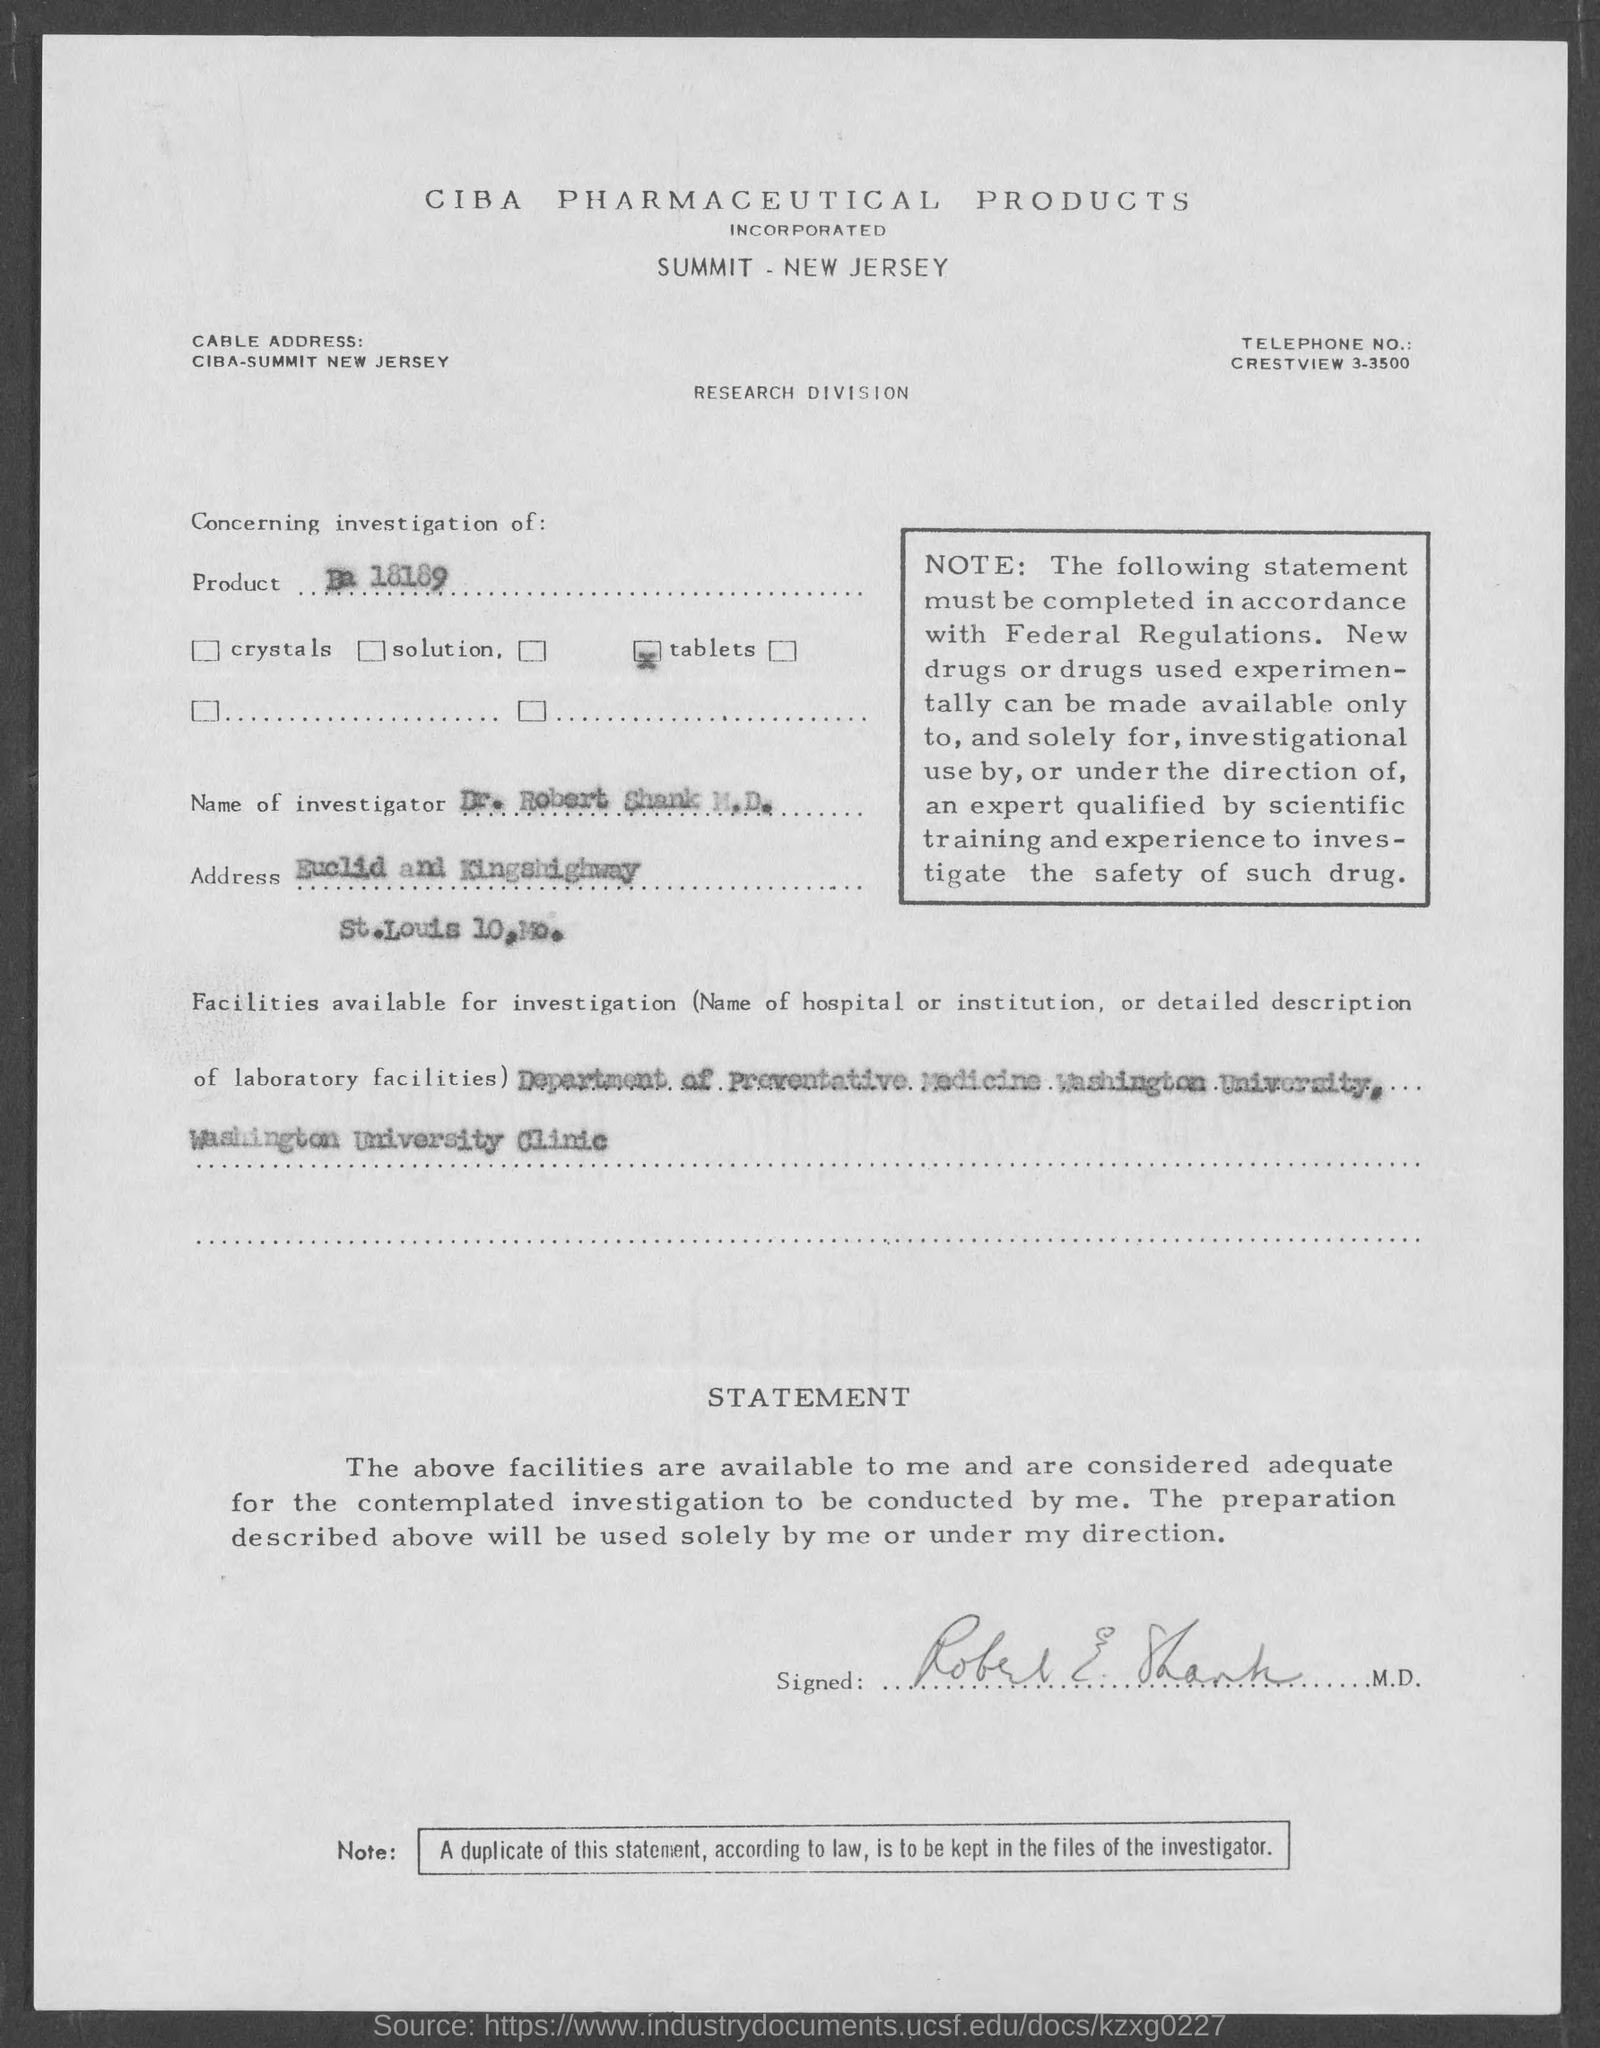Identify some key points in this picture. The name of the investigator mentioned in the document is Dr. Robert Shank M.D. The document mentions a product referred to as "Ba 18189. The facilities for investigation are available at the Department of Preventive Medicine of Washington University and the Washington University Clinic. 